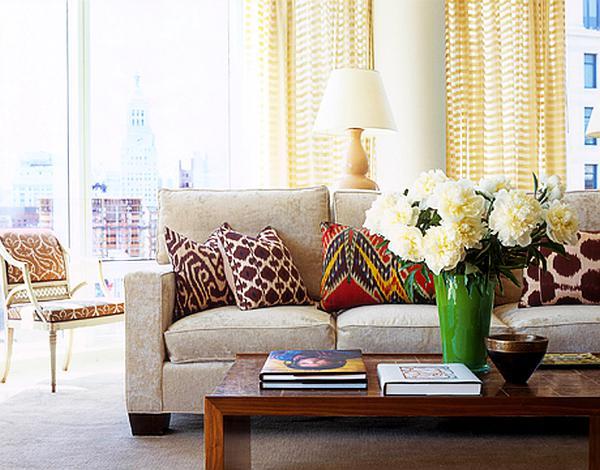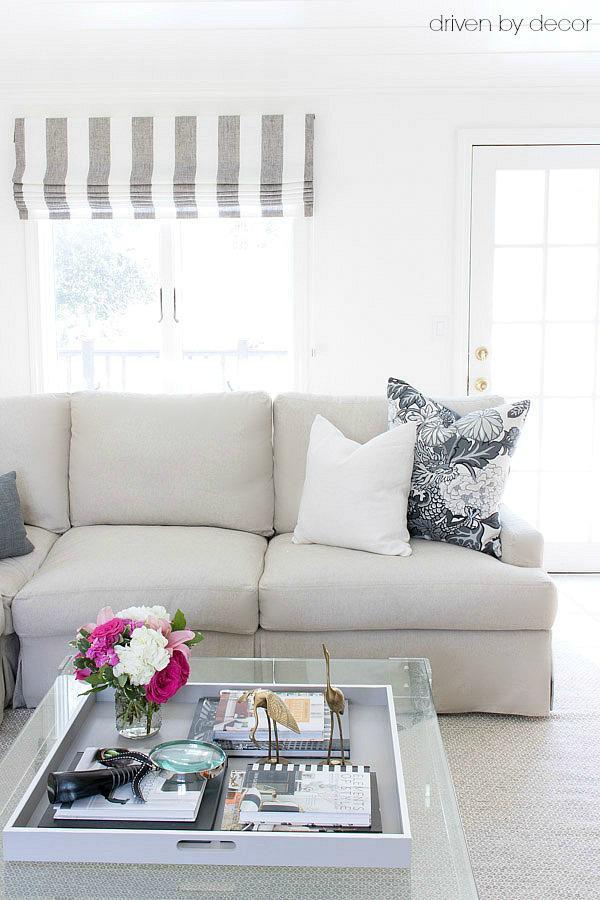The first image is the image on the left, the second image is the image on the right. Evaluate the accuracy of this statement regarding the images: "Both images show a vase of flowers sitting on top of a coffee table.". Is it true? Answer yes or no. Yes. The first image is the image on the left, the second image is the image on the right. Evaluate the accuracy of this statement regarding the images: "The combined images include a solid green sofa, green cylindrical shape, green plant, and green printed pillows.". Is it true? Answer yes or no. No. 